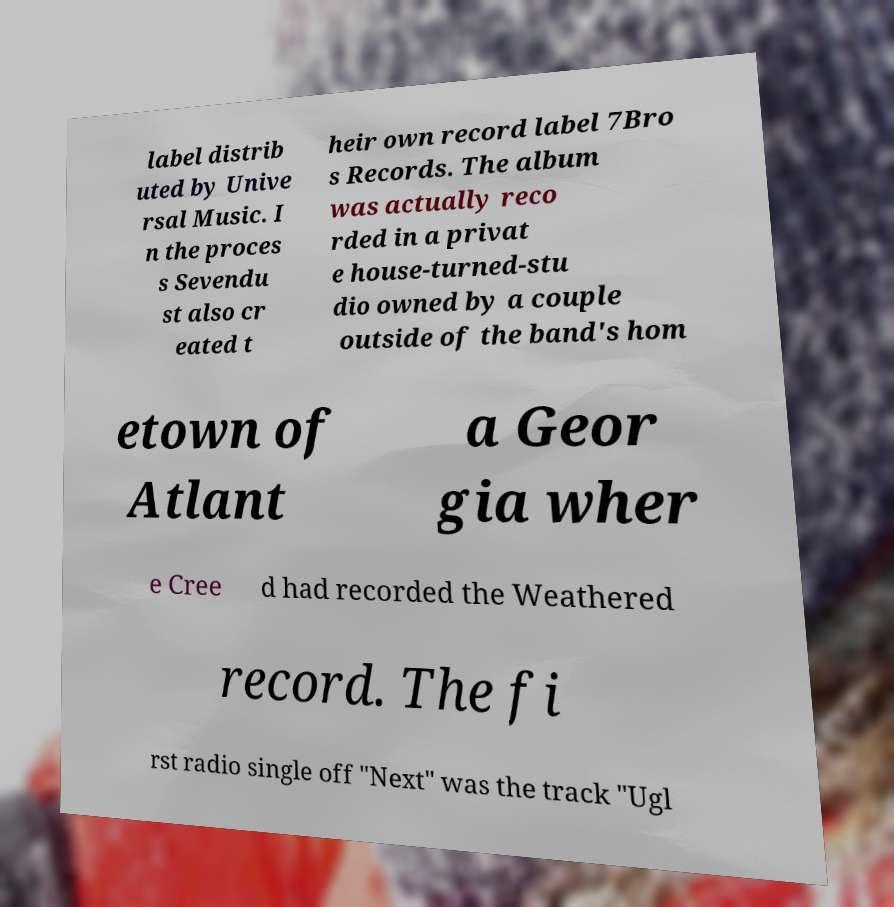Can you accurately transcribe the text from the provided image for me? label distrib uted by Unive rsal Music. I n the proces s Sevendu st also cr eated t heir own record label 7Bro s Records. The album was actually reco rded in a privat e house-turned-stu dio owned by a couple outside of the band's hom etown of Atlant a Geor gia wher e Cree d had recorded the Weathered record. The fi rst radio single off "Next" was the track "Ugl 